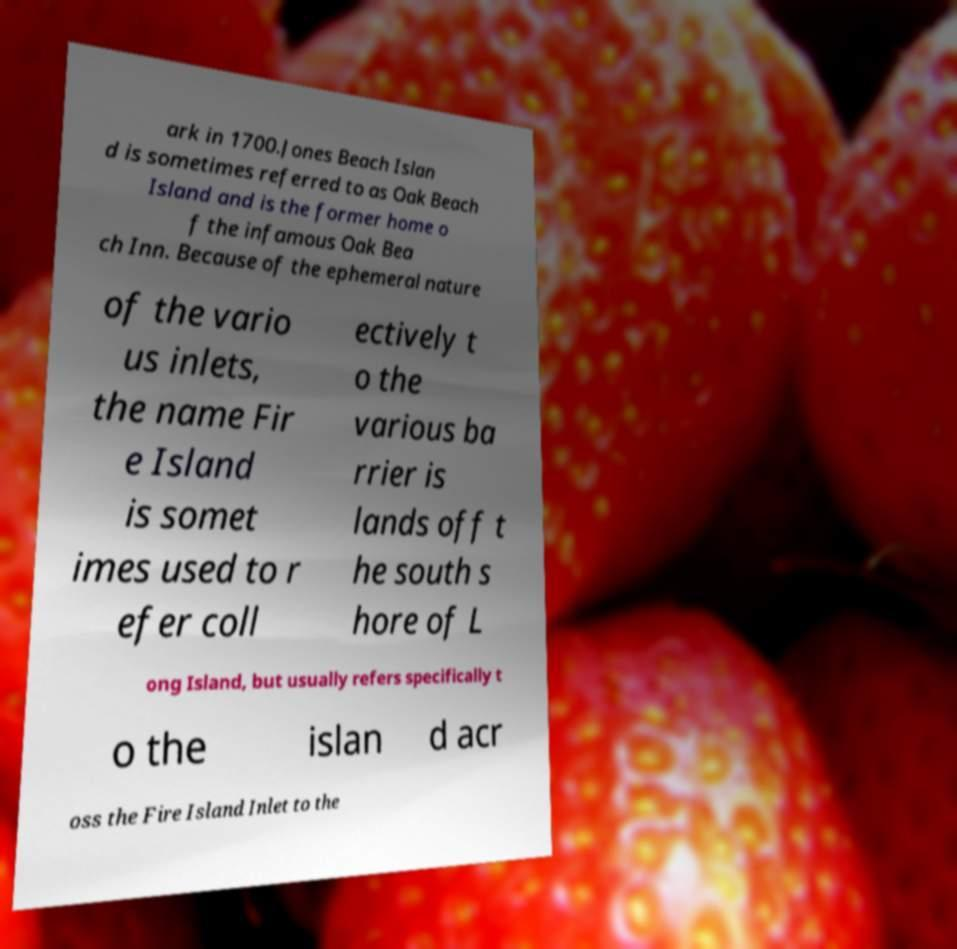Can you read and provide the text displayed in the image?This photo seems to have some interesting text. Can you extract and type it out for me? ark in 1700.Jones Beach Islan d is sometimes referred to as Oak Beach Island and is the former home o f the infamous Oak Bea ch Inn. Because of the ephemeral nature of the vario us inlets, the name Fir e Island is somet imes used to r efer coll ectively t o the various ba rrier is lands off t he south s hore of L ong Island, but usually refers specifically t o the islan d acr oss the Fire Island Inlet to the 